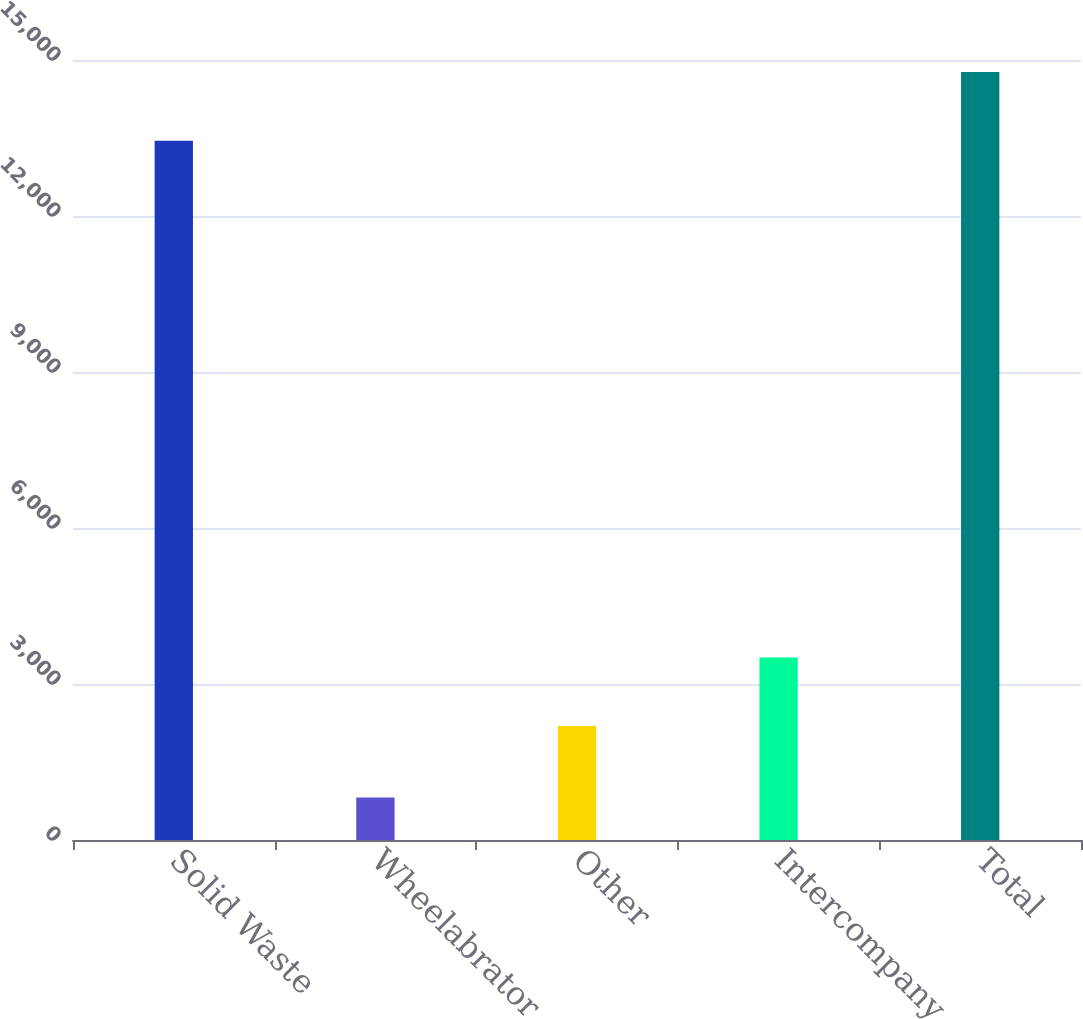Convert chart to OTSL. <chart><loc_0><loc_0><loc_500><loc_500><bar_chart><fcel>Solid Waste<fcel>Wheelabrator<fcel>Other<fcel>Intercompany<fcel>Total<nl><fcel>13449<fcel>817<fcel>2191<fcel>3508.9<fcel>14766.9<nl></chart> 